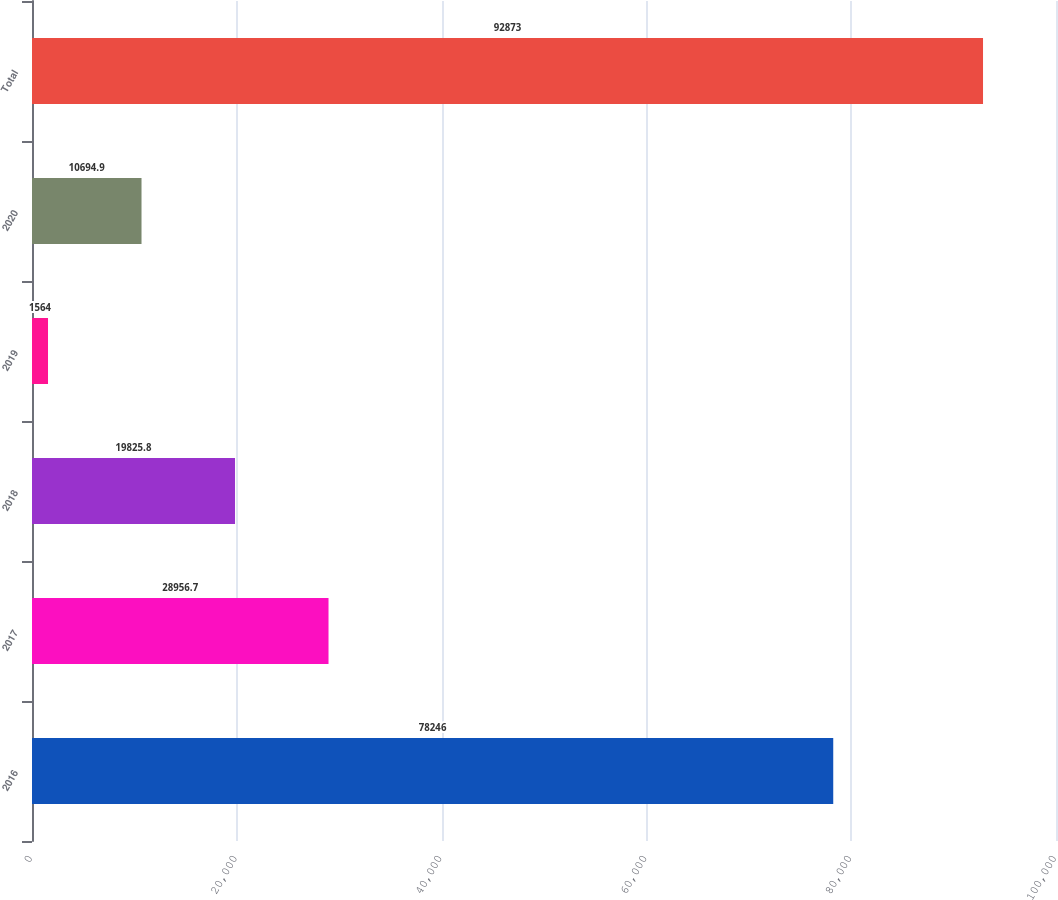Convert chart to OTSL. <chart><loc_0><loc_0><loc_500><loc_500><bar_chart><fcel>2016<fcel>2017<fcel>2018<fcel>2019<fcel>2020<fcel>Total<nl><fcel>78246<fcel>28956.7<fcel>19825.8<fcel>1564<fcel>10694.9<fcel>92873<nl></chart> 